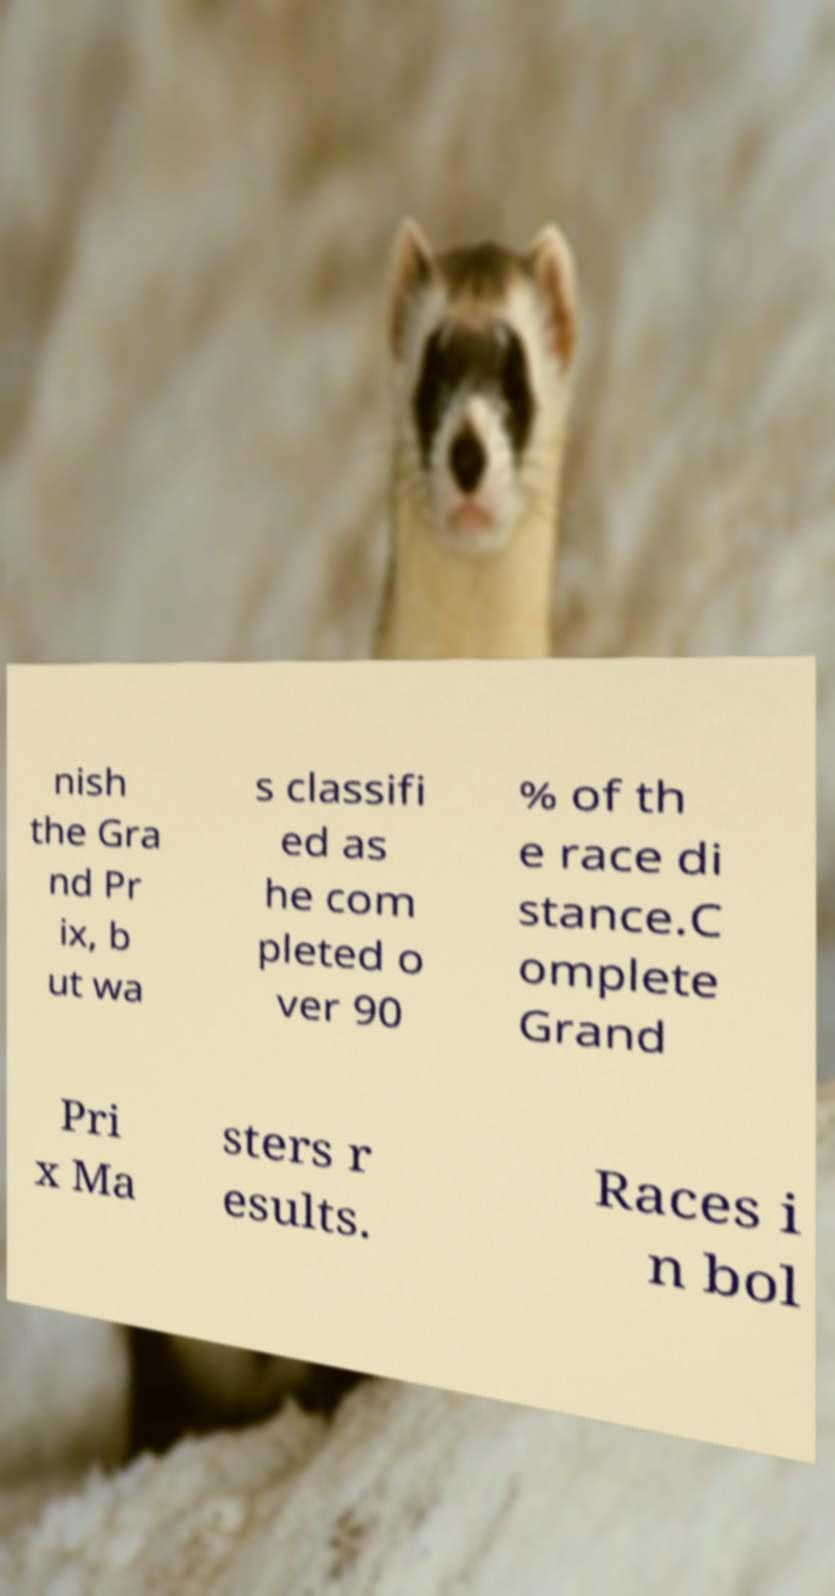Can you read and provide the text displayed in the image?This photo seems to have some interesting text. Can you extract and type it out for me? nish the Gra nd Pr ix, b ut wa s classifi ed as he com pleted o ver 90 % of th e race di stance.C omplete Grand Pri x Ma sters r esults. Races i n bol 